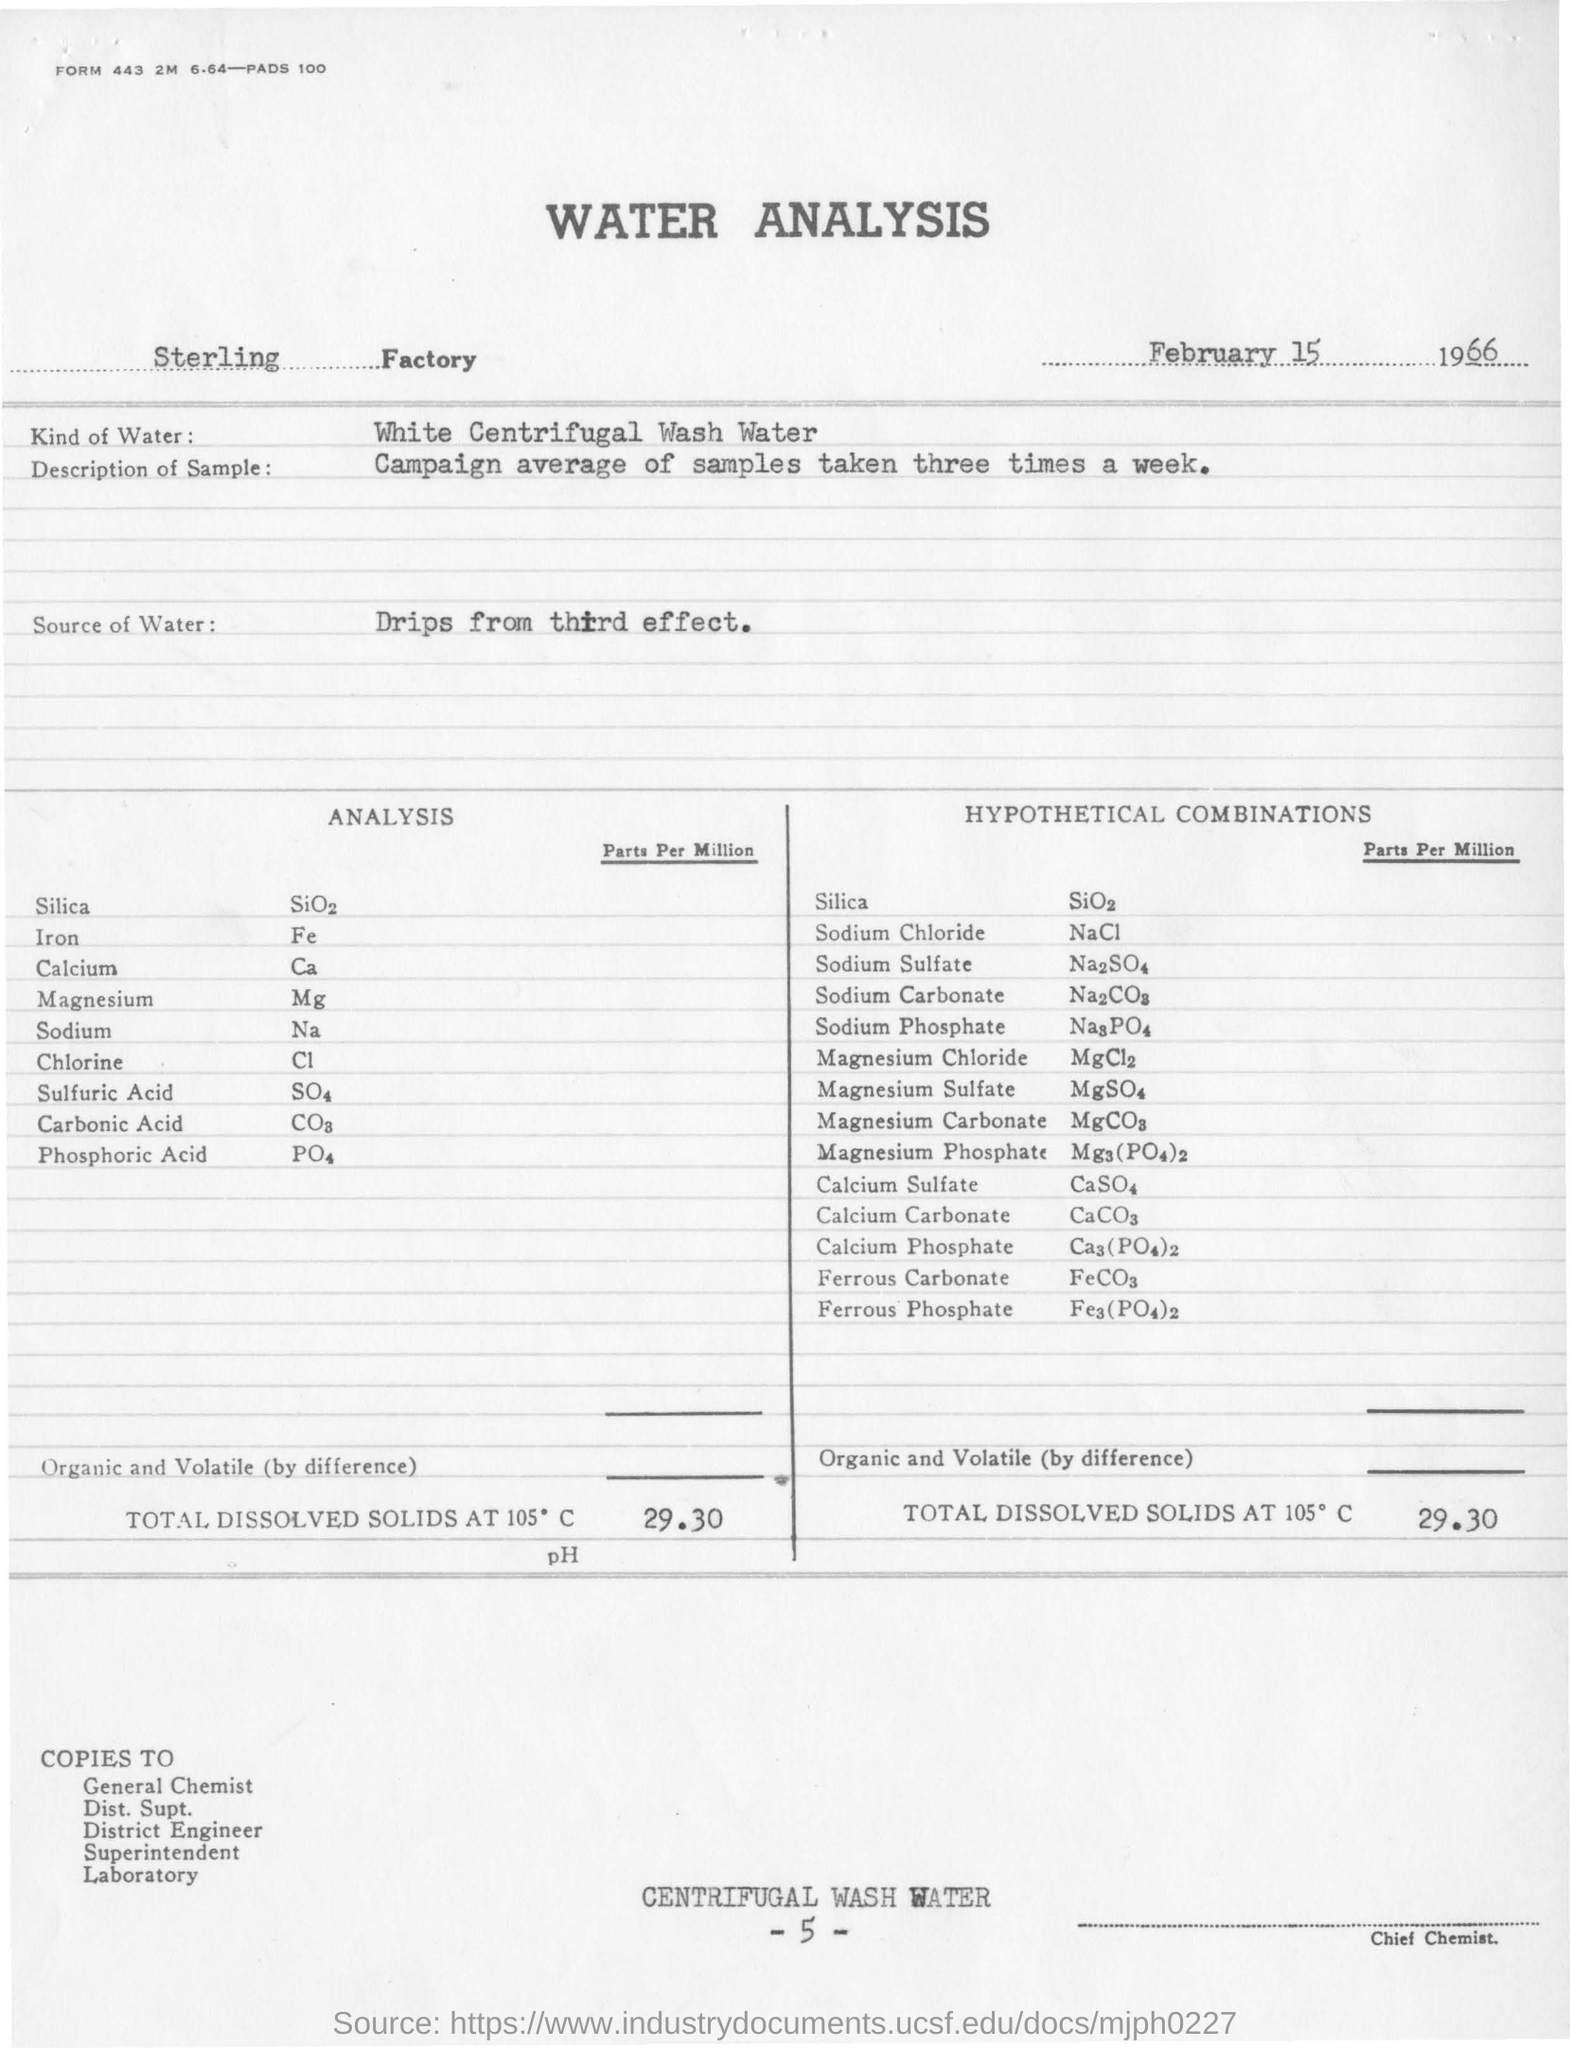Mention a couple of crucial points in this snapshot. The samples were analyzed a total of three times per week. The analysis used white centrifugal wash water. The date of the report is February 15, 1966. 